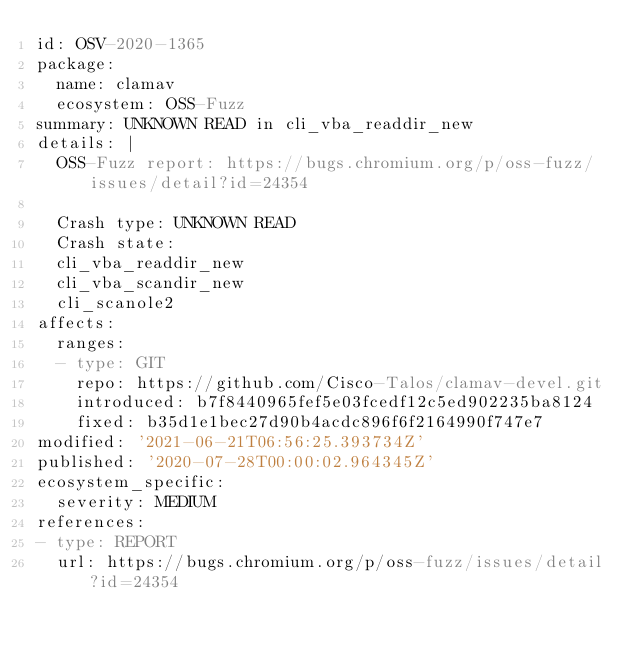<code> <loc_0><loc_0><loc_500><loc_500><_YAML_>id: OSV-2020-1365
package:
  name: clamav
  ecosystem: OSS-Fuzz
summary: UNKNOWN READ in cli_vba_readdir_new
details: |
  OSS-Fuzz report: https://bugs.chromium.org/p/oss-fuzz/issues/detail?id=24354

  Crash type: UNKNOWN READ
  Crash state:
  cli_vba_readdir_new
  cli_vba_scandir_new
  cli_scanole2
affects:
  ranges:
  - type: GIT
    repo: https://github.com/Cisco-Talos/clamav-devel.git
    introduced: b7f8440965fef5e03fcedf12c5ed902235ba8124
    fixed: b35d1e1bec27d90b4acdc896f6f2164990f747e7
modified: '2021-06-21T06:56:25.393734Z'
published: '2020-07-28T00:00:02.964345Z'
ecosystem_specific:
  severity: MEDIUM
references:
- type: REPORT
  url: https://bugs.chromium.org/p/oss-fuzz/issues/detail?id=24354
</code> 